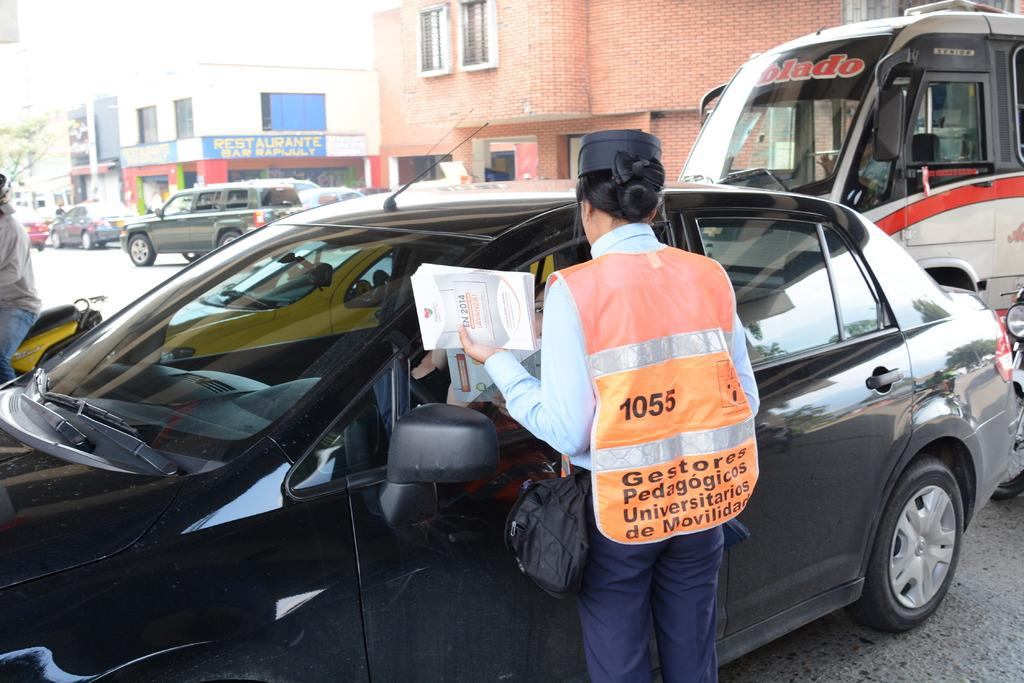Provide a one-sentence caption for the provided image. a vest with the number 1055 on the back of it. 